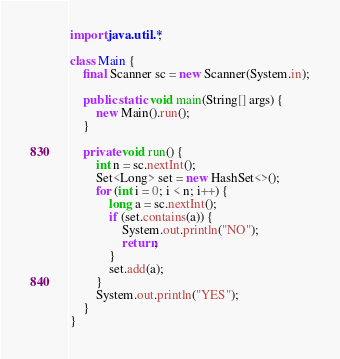<code> <loc_0><loc_0><loc_500><loc_500><_Java_>import java.util.*;

class Main {
    final Scanner sc = new Scanner(System.in);

    public static void main(String[] args) {
        new Main().run();
    }

    private void run() {
        int n = sc.nextInt();
        Set<Long> set = new HashSet<>();
        for (int i = 0; i < n; i++) {
            long a = sc.nextInt();
            if (set.contains(a)) {
                System.out.println("NO");
                return;
            }
            set.add(a);
        }
        System.out.println("YES");
    }
}
</code> 